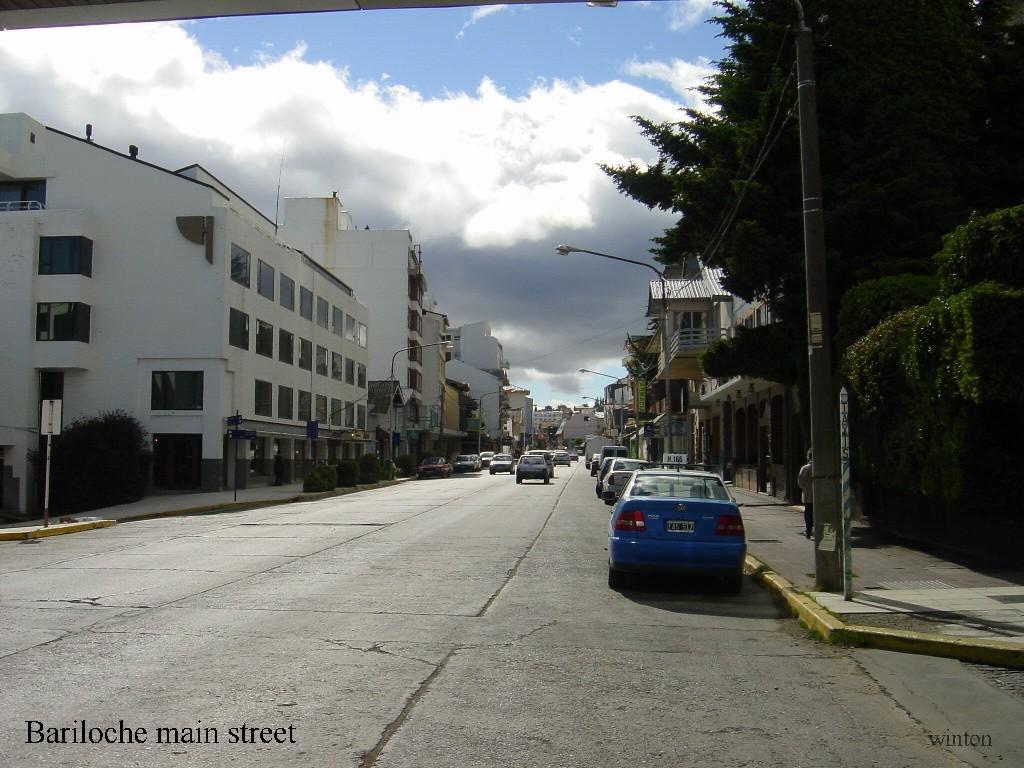How would you summarize this image in a sentence or two? In this picture we can see a few vehicles on the road. There is a text on the left side. We can see street lights, trees and buildings in the background. Sky is blue in color. 